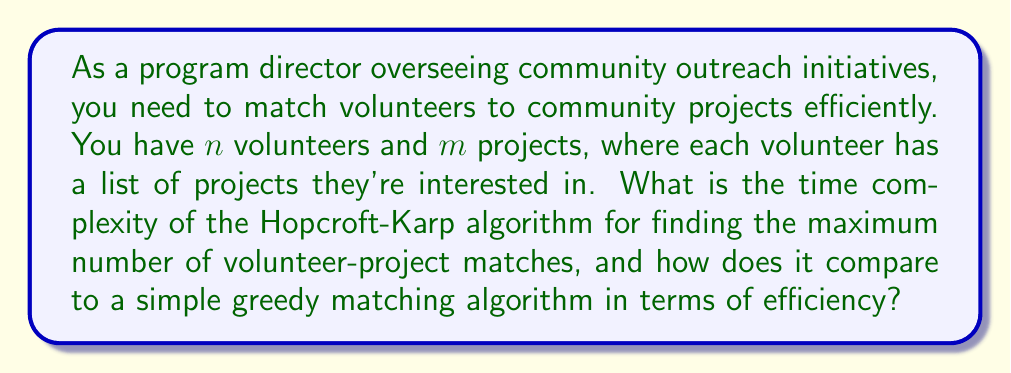Show me your answer to this math problem. To solve this problem, we need to understand the algorithms involved and analyze their time complexities:

1. Hopcroft-Karp Algorithm:
   The Hopcroft-Karp algorithm is used for finding maximum matchings in bipartite graphs. In our case, volunteers and projects form a bipartite graph.

   Time Complexity: $O(E\sqrt{V})$, where $E$ is the number of edges (volunteer-project interests) and $V$ is the number of vertices (volunteers + projects).

   In our scenario:
   - $V = n + m$ (total number of volunteers and projects)
   - $E \leq nm$ (worst case: each volunteer is interested in all projects)

   Therefore, the time complexity is $O(nm\sqrt{n+m})$

2. Simple Greedy Matching Algorithm:
   A greedy algorithm would iterate through all volunteers and assign them to the first available project they're interested in.

   Time Complexity: $O(nm)$

   This is because, in the worst case, for each volunteer (n), we might need to check all projects (m).

Comparison:
- Hopcroft-Karp: $O(nm\sqrt{n+m})$
- Greedy: $O(nm)$

The Hopcroft-Karp algorithm has a worse time complexity due to the $\sqrt{n+m}$ factor. However, it guarantees finding the maximum matching, while the greedy algorithm doesn't.

In practice:
1. For small to medium-sized inputs, the greedy algorithm might be faster and simpler to implement.
2. For large inputs or when an optimal matching is crucial, Hopcroft-Karp would be preferred despite its higher time complexity.

The choice between these algorithms depends on the specific requirements of the community outreach program, such as the number of volunteers and projects, and whether finding the absolute maximum number of matches is essential.
Answer: The time complexity of the Hopcroft-Karp algorithm for matching $n$ volunteers to $m$ projects is $O(nm\sqrt{n+m})$, which is asymptotically less efficient than the simple greedy matching algorithm with time complexity $O(nm)$. However, Hopcroft-Karp guarantees an optimal matching, while the greedy algorithm does not. 